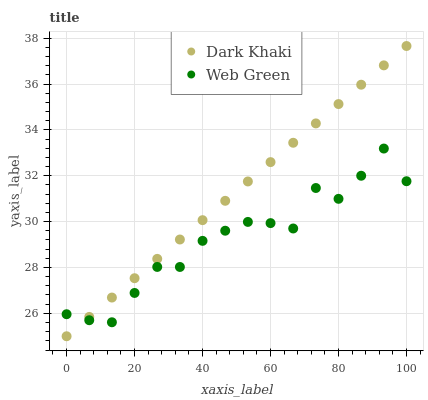Does Web Green have the minimum area under the curve?
Answer yes or no. Yes. Does Dark Khaki have the maximum area under the curve?
Answer yes or no. Yes. Does Web Green have the maximum area under the curve?
Answer yes or no. No. Is Dark Khaki the smoothest?
Answer yes or no. Yes. Is Web Green the roughest?
Answer yes or no. Yes. Is Web Green the smoothest?
Answer yes or no. No. Does Dark Khaki have the lowest value?
Answer yes or no. Yes. Does Web Green have the lowest value?
Answer yes or no. No. Does Dark Khaki have the highest value?
Answer yes or no. Yes. Does Web Green have the highest value?
Answer yes or no. No. Does Dark Khaki intersect Web Green?
Answer yes or no. Yes. Is Dark Khaki less than Web Green?
Answer yes or no. No. Is Dark Khaki greater than Web Green?
Answer yes or no. No. 